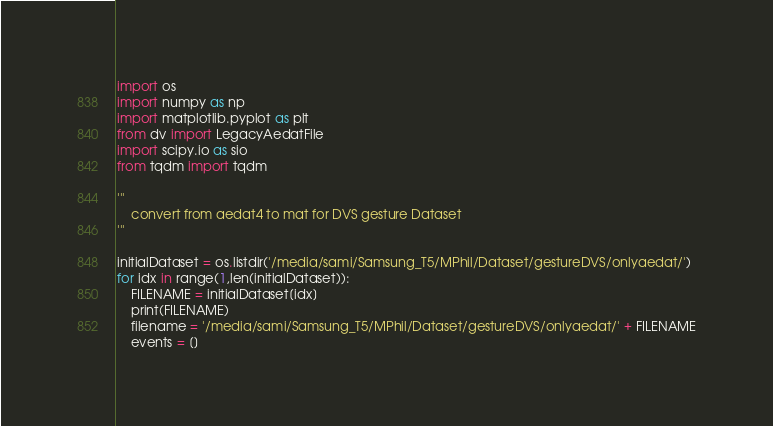Convert code to text. <code><loc_0><loc_0><loc_500><loc_500><_Python_>import os
import numpy as np
import matplotlib.pyplot as plt
from dv import LegacyAedatFile
import scipy.io as sio
from tqdm import tqdm

'''
    convert from aedat4 to mat for DVS gesture Dataset
'''

initialDataset = os.listdir('/media/sami/Samsung_T5/MPhil/Dataset/gestureDVS/onlyaedat/')
for idx in range(1,len(initialDataset)):
    FILENAME = initialDataset[idx]
    print(FILENAME)
    filename = '/media/sami/Samsung_T5/MPhil/Dataset/gestureDVS/onlyaedat/' + FILENAME
    events = []
</code> 